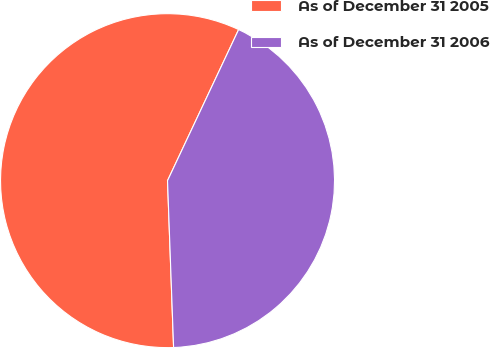Convert chart. <chart><loc_0><loc_0><loc_500><loc_500><pie_chart><fcel>As of December 31 2005<fcel>As of December 31 2006<nl><fcel>57.58%<fcel>42.42%<nl></chart> 